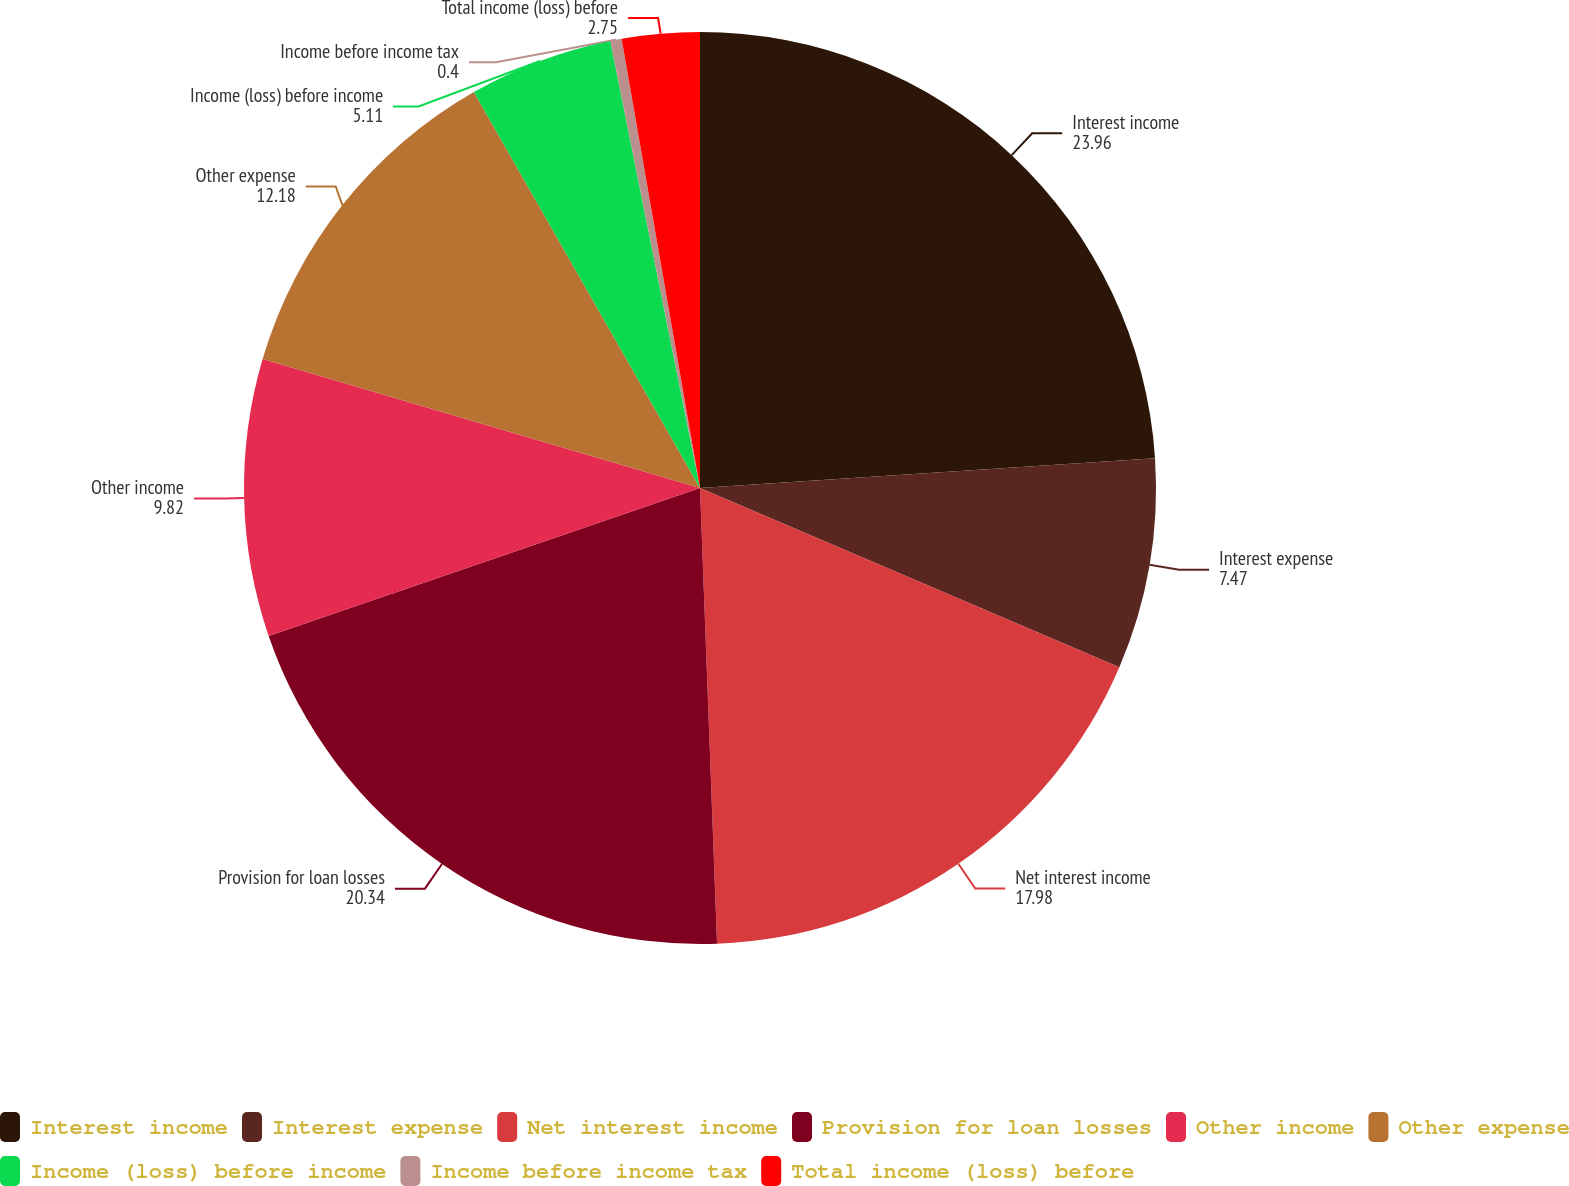Convert chart to OTSL. <chart><loc_0><loc_0><loc_500><loc_500><pie_chart><fcel>Interest income<fcel>Interest expense<fcel>Net interest income<fcel>Provision for loan losses<fcel>Other income<fcel>Other expense<fcel>Income (loss) before income<fcel>Income before income tax<fcel>Total income (loss) before<nl><fcel>23.96%<fcel>7.47%<fcel>17.98%<fcel>20.34%<fcel>9.82%<fcel>12.18%<fcel>5.11%<fcel>0.4%<fcel>2.75%<nl></chart> 